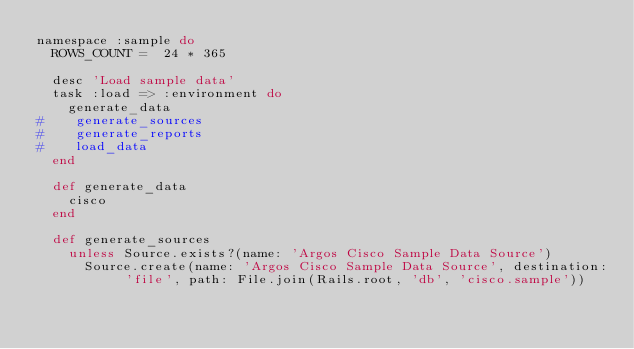<code> <loc_0><loc_0><loc_500><loc_500><_Ruby_>namespace :sample do
  ROWS_COUNT =  24 * 365

  desc 'Load sample data'
  task :load => :environment do
    generate_data
#    generate_sources
#    generate_reports
#    load_data
  end

  def generate_data
    cisco
  end

  def generate_sources
    unless Source.exists?(name: 'Argos Cisco Sample Data Source')
      Source.create(name: 'Argos Cisco Sample Data Source', destination: 'file', path: File.join(Rails.root, 'db', 'cisco.sample'))</code> 